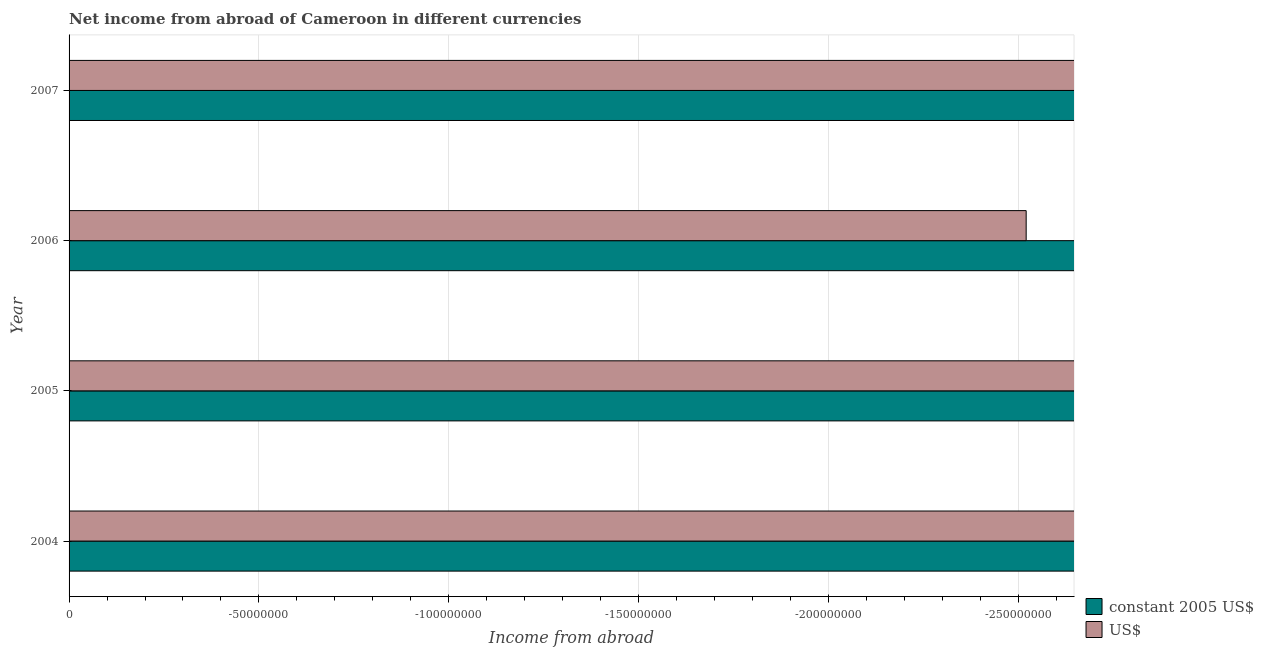Are the number of bars on each tick of the Y-axis equal?
Your response must be concise. Yes. How many bars are there on the 2nd tick from the top?
Your answer should be compact. 0. In how many cases, is the number of bars for a given year not equal to the number of legend labels?
Give a very brief answer. 4. Across all years, what is the minimum income from abroad in constant 2005 us$?
Your response must be concise. 0. What is the total income from abroad in us$ in the graph?
Provide a succinct answer. 0. What is the difference between the income from abroad in constant 2005 us$ in 2007 and the income from abroad in us$ in 2005?
Your response must be concise. 0. Are all the bars in the graph horizontal?
Keep it short and to the point. Yes. Does the graph contain any zero values?
Your answer should be compact. Yes. How many legend labels are there?
Keep it short and to the point. 2. What is the title of the graph?
Offer a very short reply. Net income from abroad of Cameroon in different currencies. Does "Infant" appear as one of the legend labels in the graph?
Offer a terse response. No. What is the label or title of the X-axis?
Make the answer very short. Income from abroad. What is the label or title of the Y-axis?
Offer a very short reply. Year. What is the Income from abroad in US$ in 2004?
Your answer should be very brief. 0. What is the Income from abroad of US$ in 2006?
Your answer should be very brief. 0. What is the total Income from abroad in US$ in the graph?
Your answer should be very brief. 0. 